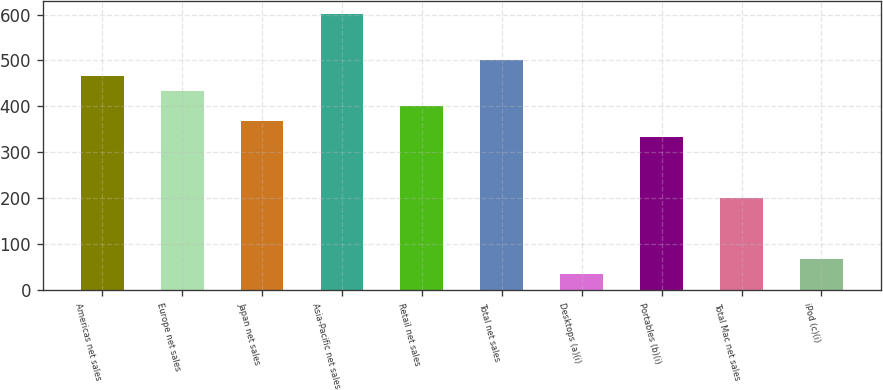<chart> <loc_0><loc_0><loc_500><loc_500><bar_chart><fcel>Americas net sales<fcel>Europe net sales<fcel>Japan net sales<fcel>Asia-Pacific net sales<fcel>Retail net sales<fcel>Total net sales<fcel>Desktops (a)(i)<fcel>Portables (b)(i)<fcel>Total Mac net sales<fcel>iPod (c)(i)<nl><fcel>467.2<fcel>433.9<fcel>367.3<fcel>600.4<fcel>400.6<fcel>500.5<fcel>34.3<fcel>334<fcel>200.8<fcel>67.6<nl></chart> 